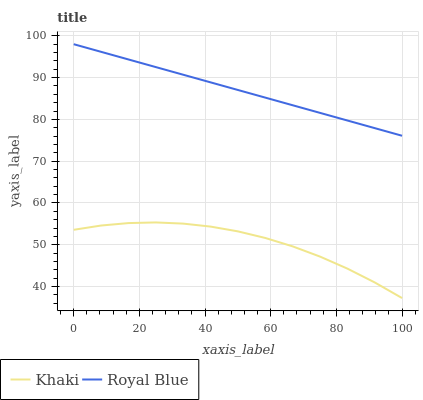Does Khaki have the minimum area under the curve?
Answer yes or no. Yes. Does Royal Blue have the maximum area under the curve?
Answer yes or no. Yes. Does Khaki have the maximum area under the curve?
Answer yes or no. No. Is Royal Blue the smoothest?
Answer yes or no. Yes. Is Khaki the roughest?
Answer yes or no. Yes. Is Khaki the smoothest?
Answer yes or no. No. Does Royal Blue have the highest value?
Answer yes or no. Yes. Does Khaki have the highest value?
Answer yes or no. No. Is Khaki less than Royal Blue?
Answer yes or no. Yes. Is Royal Blue greater than Khaki?
Answer yes or no. Yes. Does Khaki intersect Royal Blue?
Answer yes or no. No. 